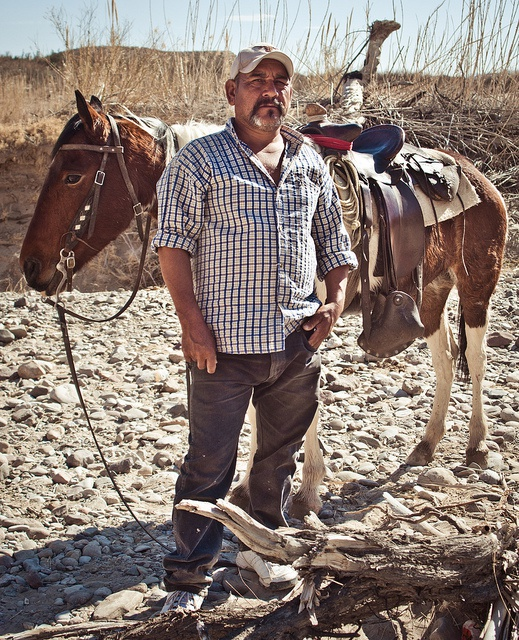Describe the objects in this image and their specific colors. I can see people in lightblue, black, maroon, gray, and darkgray tones and horse in lightblue, maroon, black, gray, and brown tones in this image. 